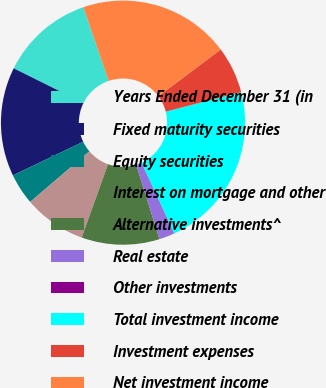<chart> <loc_0><loc_0><loc_500><loc_500><pie_chart><fcel>Years Ended December 31 (in<fcel>Fixed maturity securities<fcel>Equity securities<fcel>Interest on mortgage and other<fcel>Alternative investments^<fcel>Real estate<fcel>Other investments<fcel>Total investment income<fcel>Investment expenses<fcel>Net investment income<nl><fcel>12.39%<fcel>14.45%<fcel>4.14%<fcel>8.26%<fcel>10.33%<fcel>2.07%<fcel>0.01%<fcel>22.11%<fcel>6.2%<fcel>20.04%<nl></chart> 